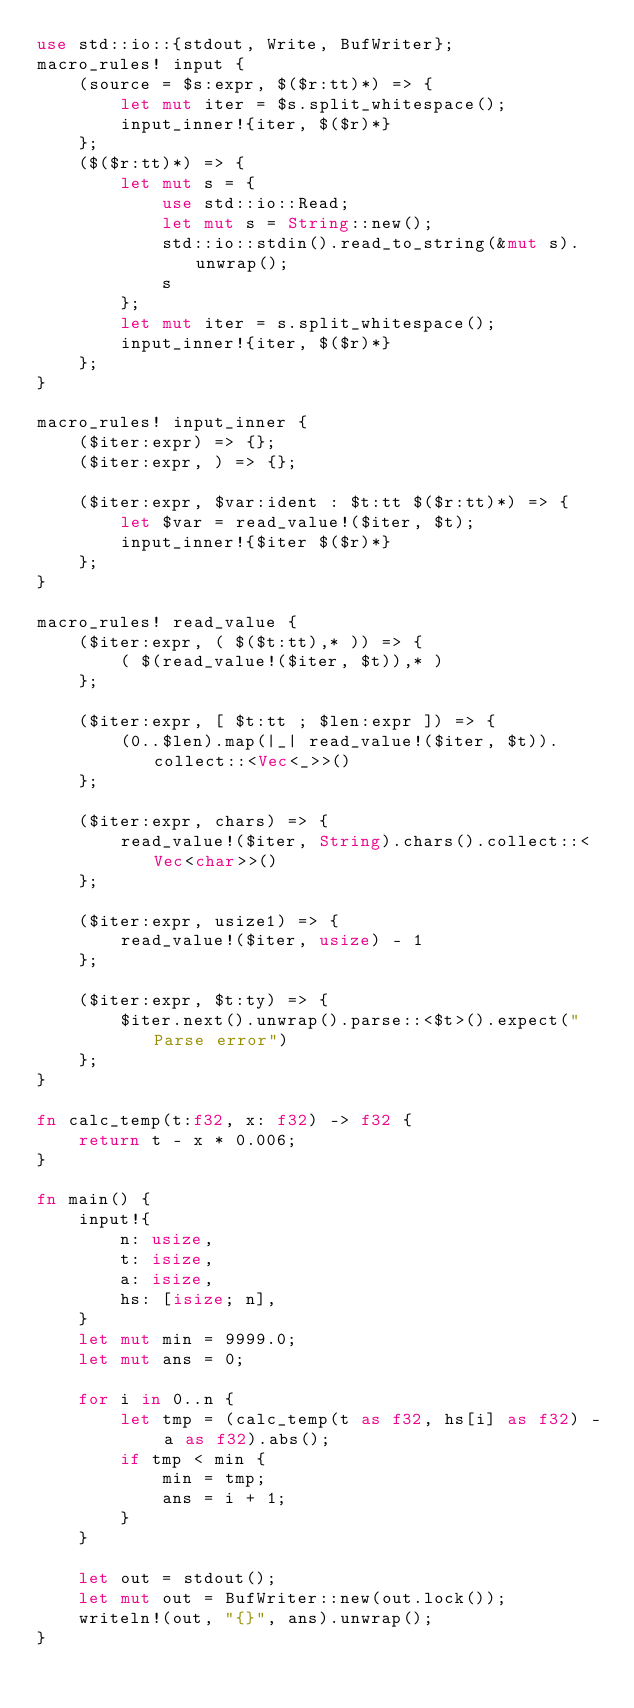<code> <loc_0><loc_0><loc_500><loc_500><_Rust_>use std::io::{stdout, Write, BufWriter};
macro_rules! input {
    (source = $s:expr, $($r:tt)*) => {
        let mut iter = $s.split_whitespace();
        input_inner!{iter, $($r)*}
    };
    ($($r:tt)*) => {
        let mut s = {
            use std::io::Read;
            let mut s = String::new();
            std::io::stdin().read_to_string(&mut s).unwrap();
            s
        };
        let mut iter = s.split_whitespace();
        input_inner!{iter, $($r)*}
    };
}

macro_rules! input_inner {
    ($iter:expr) => {};
    ($iter:expr, ) => {};

    ($iter:expr, $var:ident : $t:tt $($r:tt)*) => {
        let $var = read_value!($iter, $t);
        input_inner!{$iter $($r)*}
    };
}

macro_rules! read_value {
    ($iter:expr, ( $($t:tt),* )) => {
        ( $(read_value!($iter, $t)),* )
    };

    ($iter:expr, [ $t:tt ; $len:expr ]) => {
        (0..$len).map(|_| read_value!($iter, $t)).collect::<Vec<_>>()
    };

    ($iter:expr, chars) => {
        read_value!($iter, String).chars().collect::<Vec<char>>()
    };

    ($iter:expr, usize1) => {
        read_value!($iter, usize) - 1
    };

    ($iter:expr, $t:ty) => {
        $iter.next().unwrap().parse::<$t>().expect("Parse error")
    };
}

fn calc_temp(t:f32, x: f32) -> f32 {
    return t - x * 0.006;
}

fn main() {
    input!{
        n: usize,
        t: isize,
        a: isize,
        hs: [isize; n],
    }
    let mut min = 9999.0;
    let mut ans = 0;

    for i in 0..n {
        let tmp = (calc_temp(t as f32, hs[i] as f32) - a as f32).abs();
        if tmp < min {
            min = tmp;
            ans = i + 1;
        }
    }

    let out = stdout();
    let mut out = BufWriter::new(out.lock());
    writeln!(out, "{}", ans).unwrap();
}</code> 